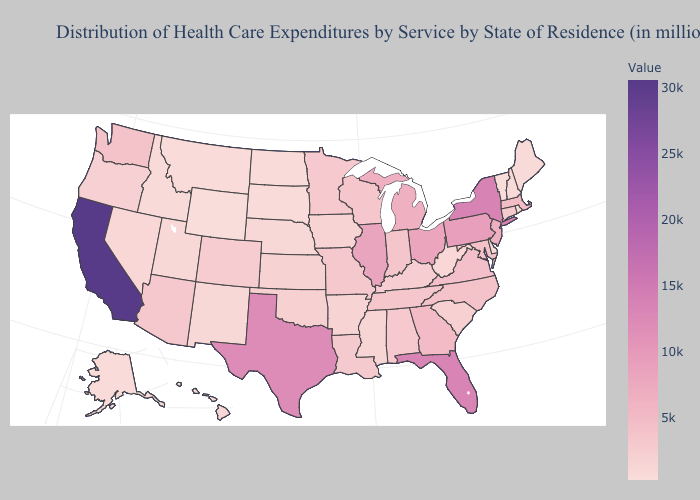Among the states that border Wisconsin , which have the highest value?
Concise answer only. Illinois. Does South Dakota have the lowest value in the MidWest?
Give a very brief answer. Yes. Is the legend a continuous bar?
Be succinct. Yes. Does Vermont have the lowest value in the USA?
Give a very brief answer. No. Does Illinois have the highest value in the MidWest?
Give a very brief answer. Yes. 